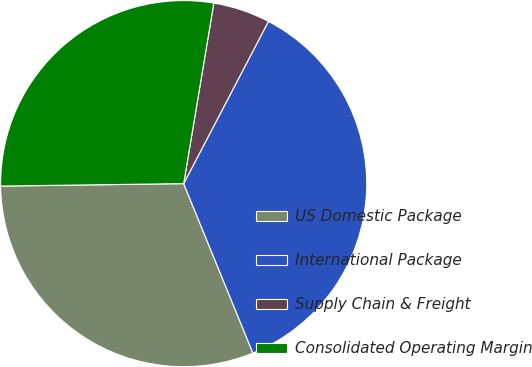<chart> <loc_0><loc_0><loc_500><loc_500><pie_chart><fcel>US Domestic Package<fcel>International Package<fcel>Supply Chain & Freight<fcel>Consolidated Operating Margin<nl><fcel>30.96%<fcel>36.16%<fcel>5.03%<fcel>27.85%<nl></chart> 